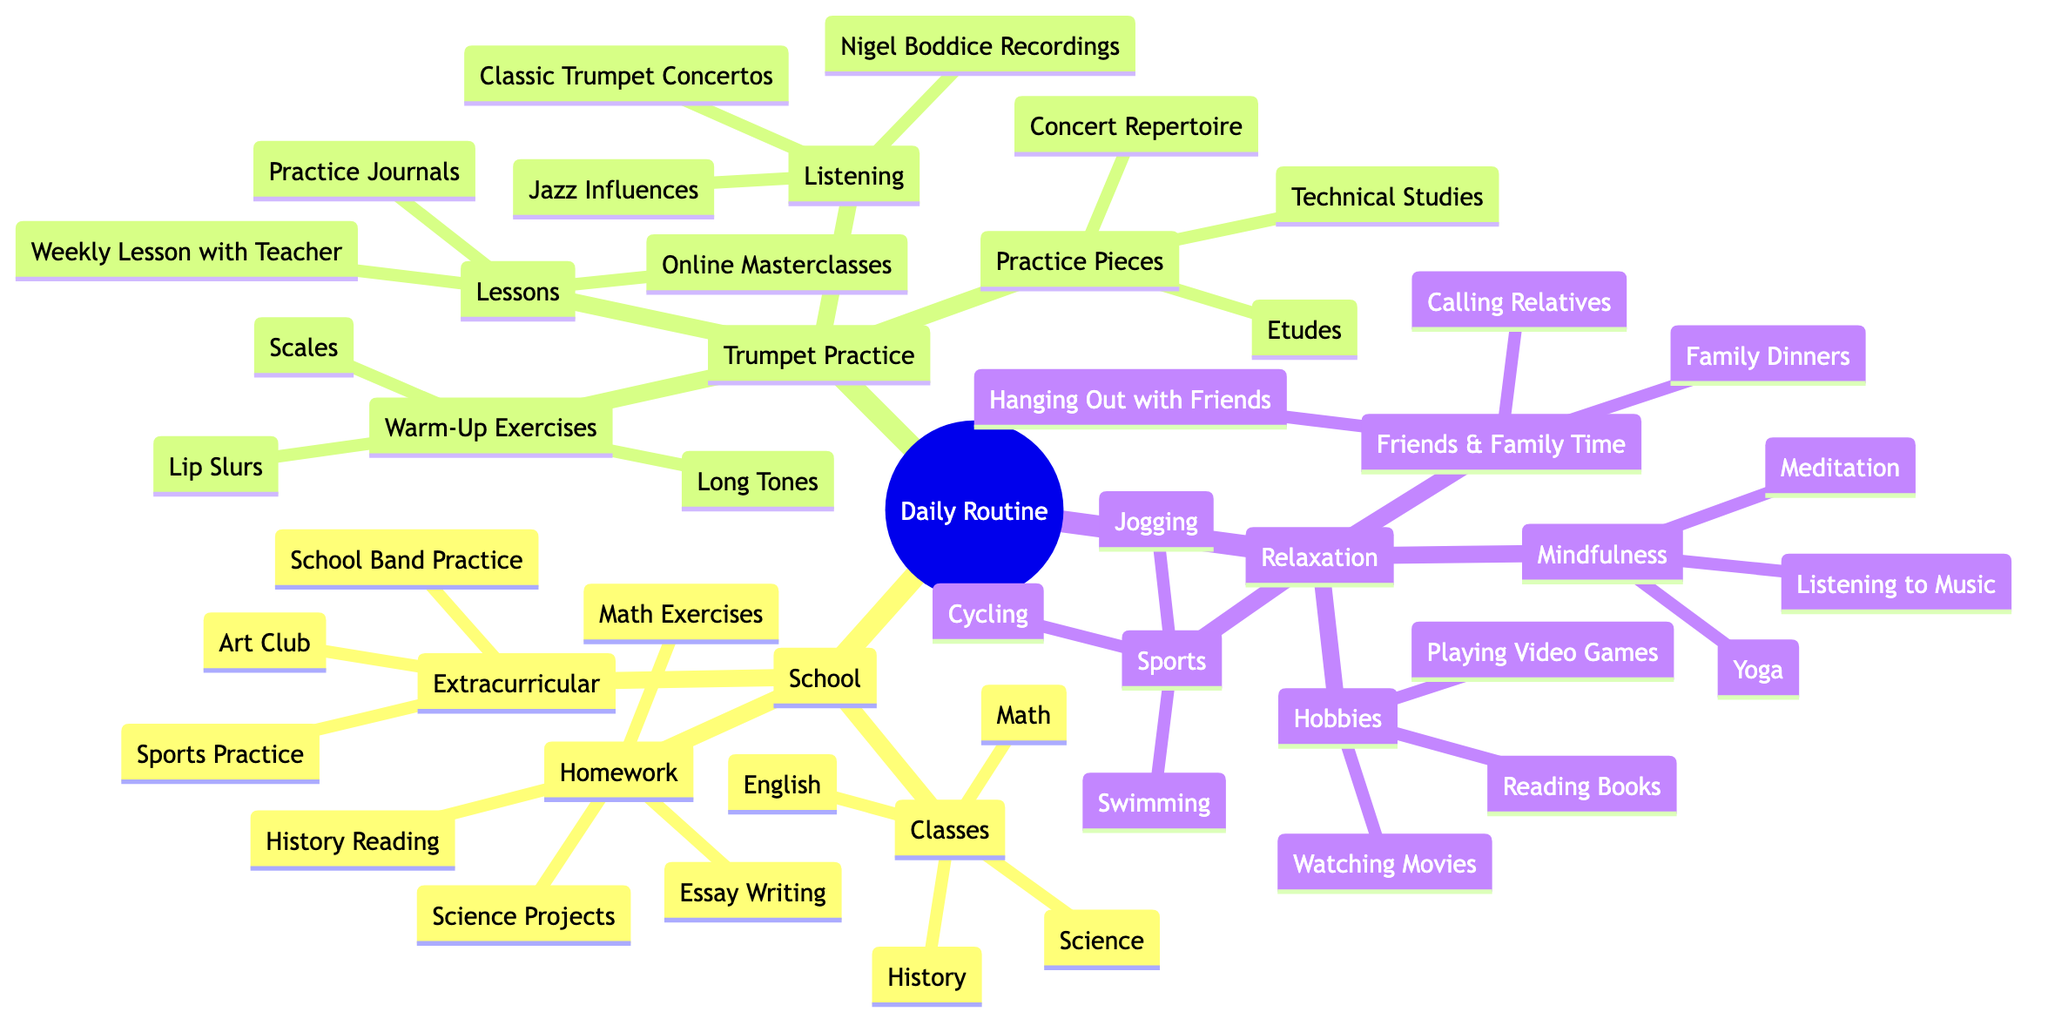What classes are included in the School category? The School category has three subcategories: Classes, Homework, and Extracurricular. Under Classes, the diagram lists Math, English, History, and Science. Therefore, these are the classes included.
Answer: Math, English, History, Science How many pieces of Listening options are in Trumpet Practice? The Trumpet Practice category has a subcategory called Listening. Within this subcategory, there are three options listed: Nigel Boddice Recordings, Classic Trumpet Concertos, and Jazz Influences. So, the total number is three.
Answer: 3 What is one activity listed under Relaxation's Mindfulness? Under the Relaxation category, there is a subcategory called Mindfulness, which lists three activities: Meditation, Yoga, and Listening to Music. Any one of these is an acceptable answer, so we can pick Meditation as an example.
Answer: Meditation Which Trumpet Practice subcategory has the most items? The Trumpet Practice category contains four subcategories: Warm-Up Exercises, Practice Pieces, Listening, and Lessons. The subcategory Practice Pieces includes three items: Technical Studies, Etudes, and Concert Repertoire. All other subcategories have either three or fewer. Therefore, none of these subcategories exceed the three items in Practice Pieces.
Answer: Practice Pieces What extracurricular activities are available in School? The Extracurricular subcategory within School lists three activities: School Band Practice, Art Club, and Sports Practice. Thus, these are the available extracurricular activities.
Answer: School Band Practice, Art Club, Sports Practice What is one example of a sport listed under Relaxation? Within the Relaxation category, there is a subcategory called Sports, which includes Swimming, Jogging, and Cycling. Therefore, any one of these can be considered an example, for instance, Swimming.
Answer: Swimming How many types of practices are listed under Trumpet Practice? The Trumpet Practice category comprises four subcategories: Warm-Up Exercises, Practice Pieces, Listening, and Lessons. Therefore, the total number of types of practices is four.
Answer: 4 Are there any activities listed under Friends & Family Time? The Friends & Family Time subcategory under Relaxation lists three activities: Family Dinners, Hanging Out with Friends, and Calling Relatives. Hence, there are indeed activities in this category.
Answer: Family Dinners, Hanging Out with Friends, Calling Relatives 